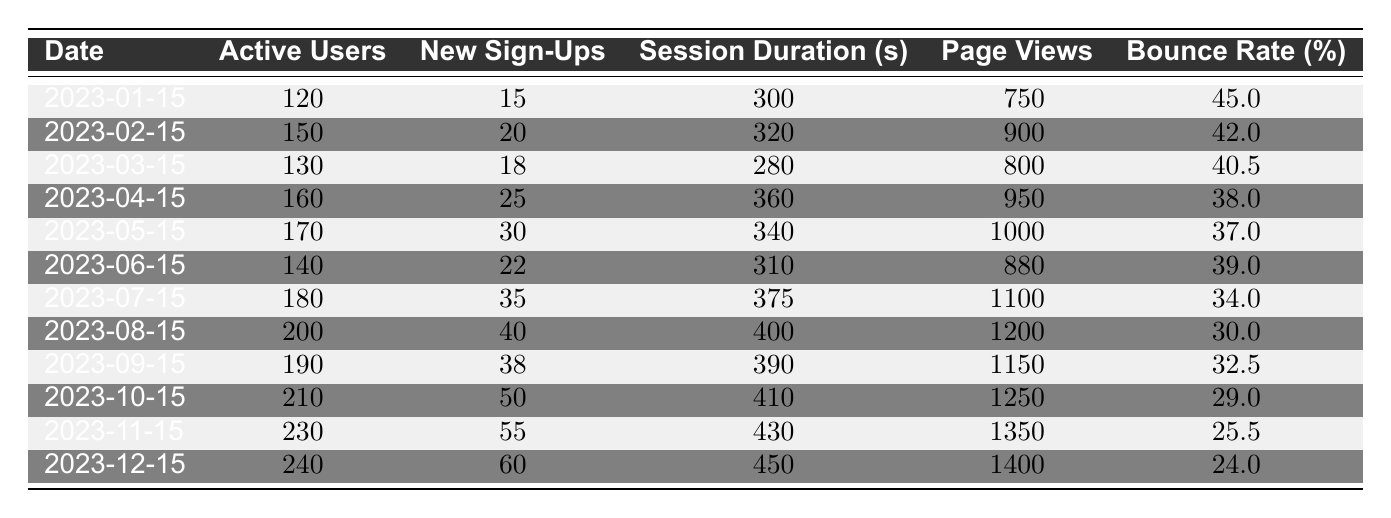What were the active users on March 15, 2023? Referring to the table, the value in the "Active Users" column for the date "2023-03-15" is 130.
Answer: 130 What was the session duration on August 15, 2023? The table shows that the session duration on "2023-08-15" is listed as 400 seconds.
Answer: 400 seconds How many new sign-ups were recorded in November 2023? Looking at the table, the new sign-ups for "2023-11-15" are recorded as 55.
Answer: 55 What is the average bounce rate for the months of June through December? The bounce rates for June to December are: 39.0, 34.0, 30.0, 32.5, 29.0, 25.5, and 24.0. The sum of these is 39.0 + 34.0 + 30.0 + 32.5 + 29.0 + 25.5 + 24.0 = 214.0. There are 7 data points, so the average is 214.0 / 7 = 30.57.
Answer: 30.57 Did the active users increase from September to October 2023? The active users in September were 190 and in October they were 210. Since 210 is greater than 190, it is true that active users increased.
Answer: Yes How many new sign-ups were there in total from January to March 2023? The new sign-ups from January to March are: 15 (Jan) + 20 (Feb) + 18 (Mar). The sum is 15 + 20 + 18 = 53.
Answer: 53 What was the maximum session duration recorded in the data? By examining the session duration values, the maximum value is found on December 15, which is 450 seconds.
Answer: 450 seconds Was the bounce rate lower in December than in January 2023? The bounce rate in January is 45.0% and in December it is 24.0%. Since 24.0% is less than 45.0%, it can be concluded that the bounce rate was indeed lower in December.
Answer: Yes What is the change in the number of active users from the start of the year (January) to the end of the year (December)? The active users in January are 120 and in December are 240. The change is 240 - 120 = 120 users.
Answer: 120 users How much did page views increase from April to May 2023? The page views in April are 950 and in May they are 1000. The increase is calculated as 1000 - 950 = 50.
Answer: 50 Was there a continuous monthly increase in new sign-ups from January to December 2023? Evaluating the new sign-ups month by month, the values are: 15, 20, 18, 25, 30, 22, 35, 40, 38, 50, 55, and 60. There is no continuous increase as the sign-up numbers decreased from February to March (20 to 18).
Answer: No 